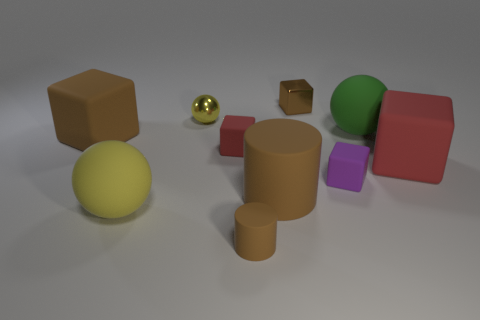Subtract all purple blocks. How many blocks are left? 4 Subtract all purple rubber cubes. How many cubes are left? 4 Subtract all yellow blocks. Subtract all brown balls. How many blocks are left? 5 Subtract all cylinders. How many objects are left? 8 Add 5 big yellow cubes. How many big yellow cubes exist? 5 Subtract 0 gray blocks. How many objects are left? 10 Subtract all big red cubes. Subtract all green objects. How many objects are left? 8 Add 6 big balls. How many big balls are left? 8 